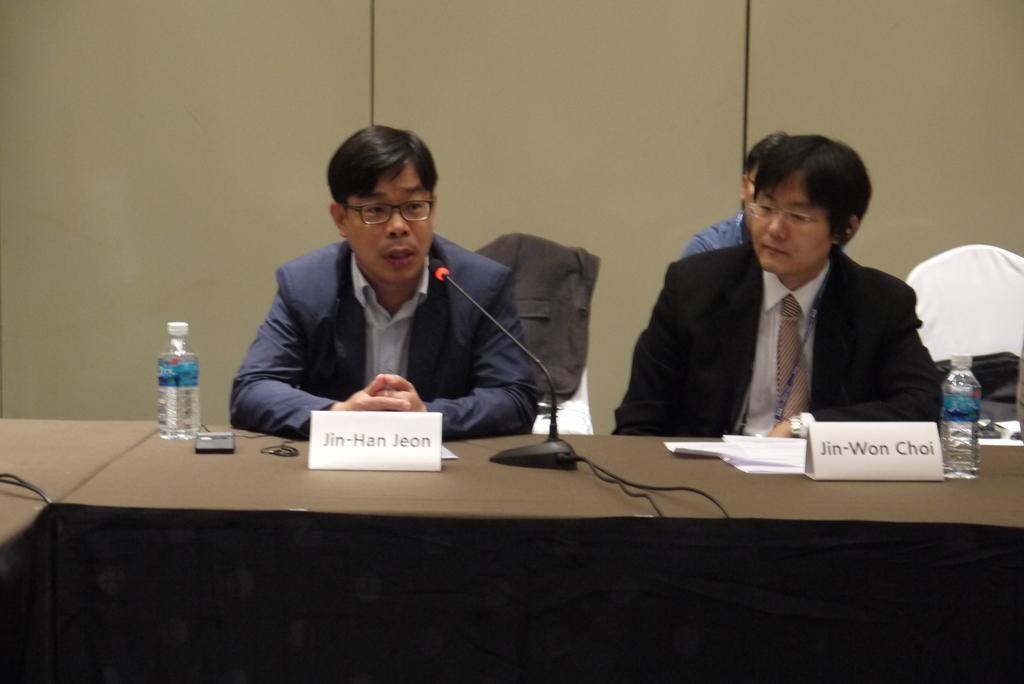Can you describe this image briefly? In this image we can see two persons with glasses and wearing suits and sitting on the chairs in front of the table. On the table we can see the water bottles, mobile phone, name boards and also the mike with the stand and also wires. In the background we can see the wall, a chair and also some other person. 